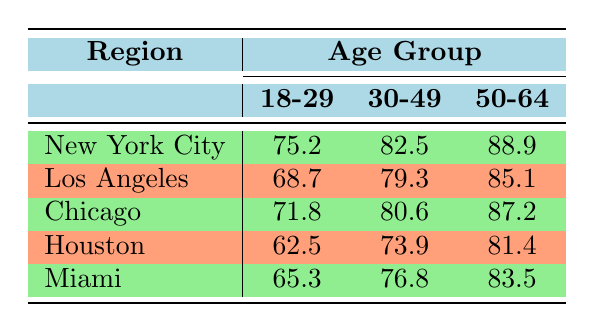What is the vaccination rate for the 50-64 age group in New York City? The table shows that the vaccination rate for the 50-64 age group in the New York City region is 88.9.
Answer: 88.9 Which city has the highest vaccination rate for the 18-29 age group? From the table, New York City has the highest vaccination rate for the 18-29 age group at 75.2, compared to Los Angeles (68.7), Chicago (71.8), Houston (62.5), and Miami (65.3).
Answer: New York City What is the percentage difference in vaccination rates for the 30-49 age group between Chicago and Houston? Chicago has a vaccination rate of 80.6, while Houston's rate is 73.9. To find the percentage difference, subtract Houston's rate from Chicago's (80.6 - 73.9 = 6.7) and divide by Houston's rate (6.7 / 73.9 ≈ 0.0905). Multiply by 100 to convert to percentage (0.0905 * 100 ≈ 9.05%).
Answer: About 9.05% Is the vaccination rate for the 50-64 age group in Miami higher than in Los Angeles? The table indicates that the vaccination rate for the 50-64 age group in Miami is 83.5 while in Los Angeles it is 85.1. Since 83.5 is less than 85.1, the statement is false.
Answer: No What is the average vaccination rate for the 30-49 age group across all regions? The vaccination rates for the 30-49 age group are: New York City (82.5), Los Angeles (79.3), Chicago (80.6), Houston (73.9), and Miami (76.8). Summing these gives us (82.5 + 79.3 + 80.6 + 73.9 + 76.8 = 393.1). Then we divide by the number of regions (393.1 / 5 = 78.62).
Answer: 78.62 Which age group in Houston had the lowest vaccination rate? The table shows that in Houston, the vaccination rates for different age groups are: 18-29 (62.5), 30-49 (73.9), and 50-64 (81.4). The lowest rate is for the 18-29 age group at 62.5.
Answer: 18-29 What is the overall vaccination rate trend as age increases from 18-29 to 50-64 across all regions? By observing the provided data, each age group appears to have higher vaccination rates as the age increases. The rates for 18-29 are all lower than those for 30-49, which are still lower than the rates for 50-64 across all five cities.
Answer: Increase Is the vaccination rate for the 30-49 age group in Los Angeles lower than in Miami? The vaccination rates for the 30-49 age group are: Los Angeles (79.3) and Miami (76.8). Since 79.3 is greater than 76.8, the statement is false.
Answer: No 